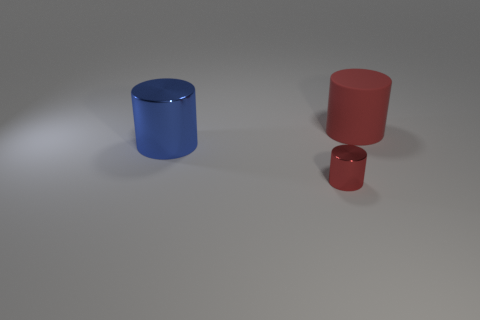Subtract all red cylinders. How many cylinders are left? 1 Add 2 large rubber things. How many objects exist? 5 Subtract all small red metal things. Subtract all large cylinders. How many objects are left? 0 Add 1 big red rubber cylinders. How many big red rubber cylinders are left? 2 Add 2 small red shiny things. How many small red shiny things exist? 3 Subtract 0 brown spheres. How many objects are left? 3 